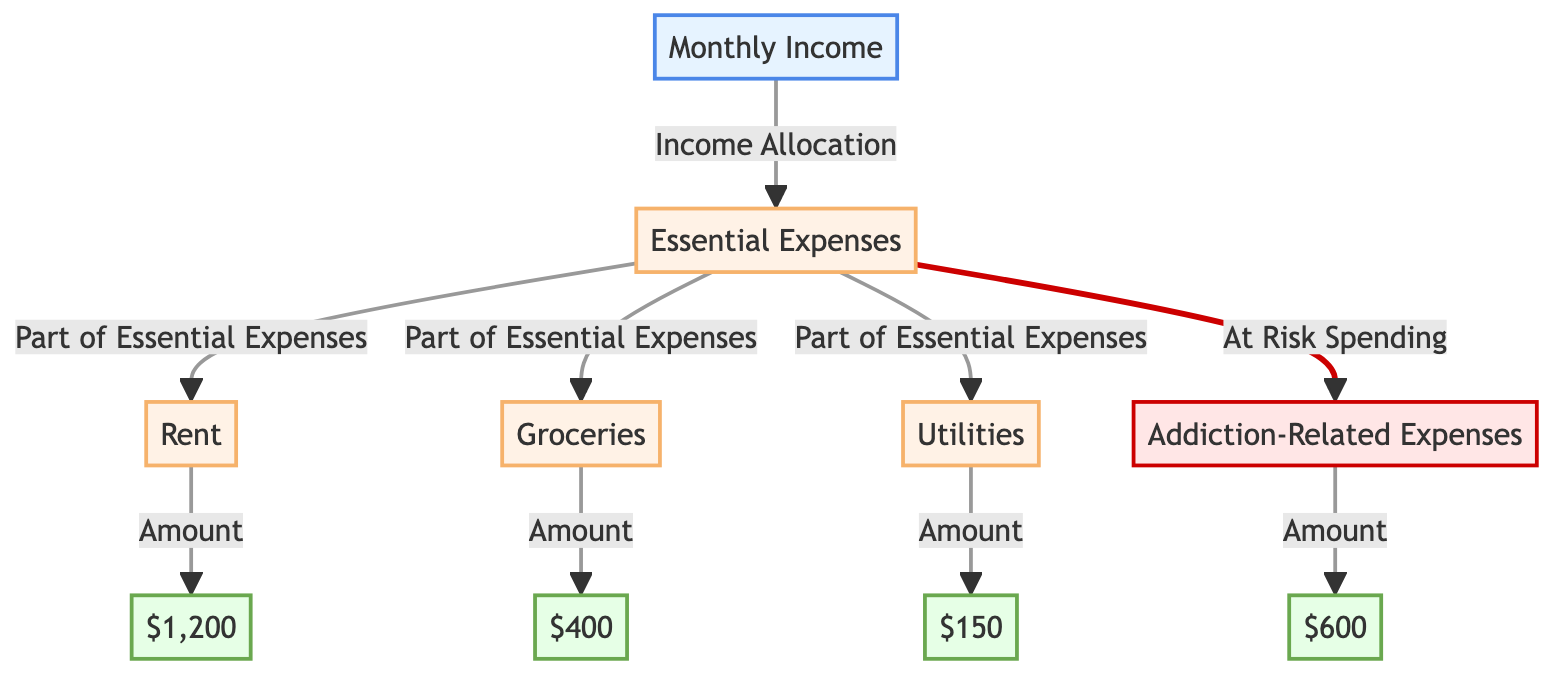What is the total monthly income? Looking at the diagram, there is a node labeled "Monthly Income" (1) which represents the total amount coming in, identified as $1,200 (7).
Answer: $1,200 How much is spent on rent? The diagram has a node labeled "Rent" (3), which shows the amount spent on this essential expense is $600 (10).
Answer: $600 What is the amount allocated for groceries? The node for "Groceries" (4) shows that the monthly spending on groceries is $400 (8).
Answer: $400 What are the total essential expenses? The total essential expenses can be derived by summing the amounts of rent ($600), groceries ($400), and utilities ($150). Hence, $600 + $400 + $150 = $1,150.
Answer: $1,150 How much is spent on gambling? According to the diagram, under the "Addiction-Related Expenses" (6), the spending on gambling is shown as $150 (10).
Answer: $150 Which essential expense has the highest allocation? By comparing the values of rent ($600), groceries ($400), and utilities ($150), it's clear that "Rent" has the highest allocation.
Answer: Rent What is the percentage of total essential expenses that goes toward gambling? To find this, first calculate the total essential expenses ($1,150 as derived previously). The percentage for gambling is calculated as ($150 / $1,150) * 100, which equals approximately 13.04%.
Answer: 13.04% How many edges are connected to the "Essential Expenses" node? The "Essential Expenses" node (2) has three edges coming from it, connecting to the Rent (3), Groceries (4), and Utilities (5) nodes, plus one edge going toward "Addiction-Related Expenses" (6). This makes a total of four edges connected to it.
Answer: 4 If the housing cost increases by $100, what would the new total essential expenses be? If rent rises from $600 to $700, the new total essential expenses would be $700 (new rent) + $400 (groceries) + $150 (utilities) = $1,250.
Answer: $1,250 